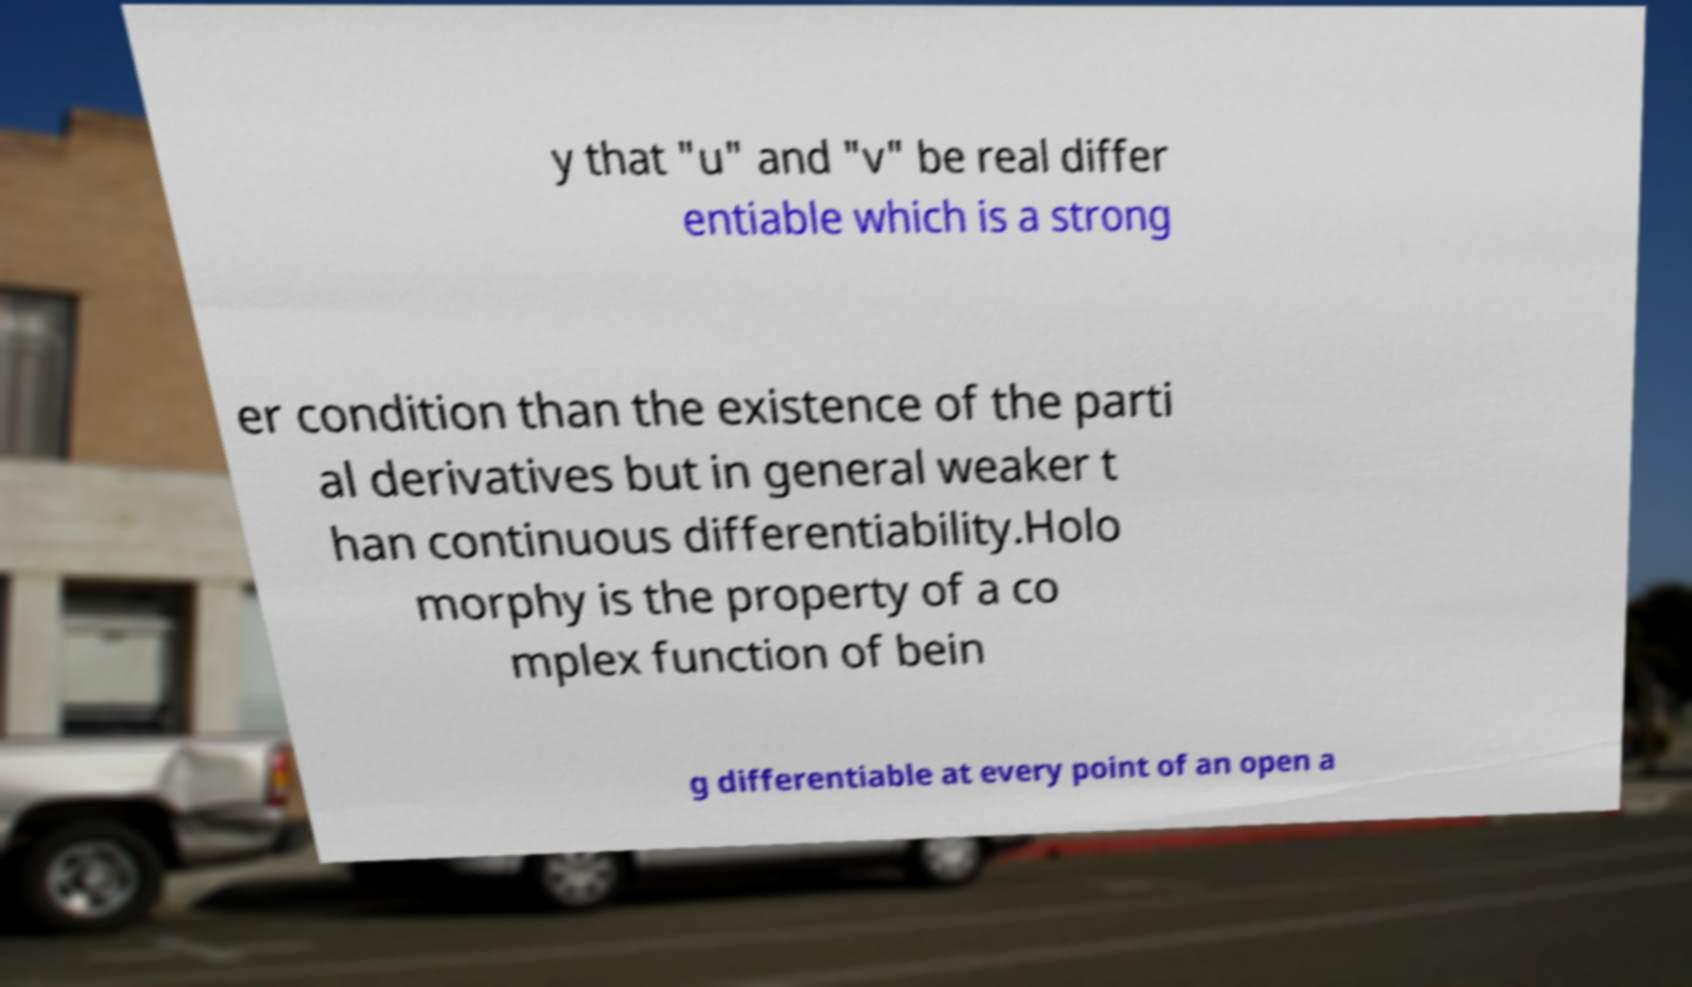Please read and relay the text visible in this image. What does it say? y that "u" and "v" be real differ entiable which is a strong er condition than the existence of the parti al derivatives but in general weaker t han continuous differentiability.Holo morphy is the property of a co mplex function of bein g differentiable at every point of an open a 